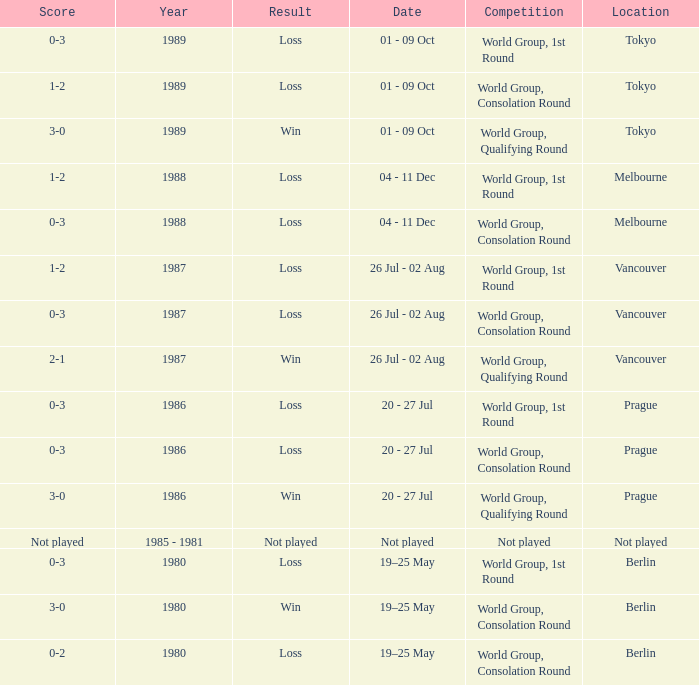What is the score when the result is loss, the year is 1980 and the competition is world group, consolation round? 0-2. 